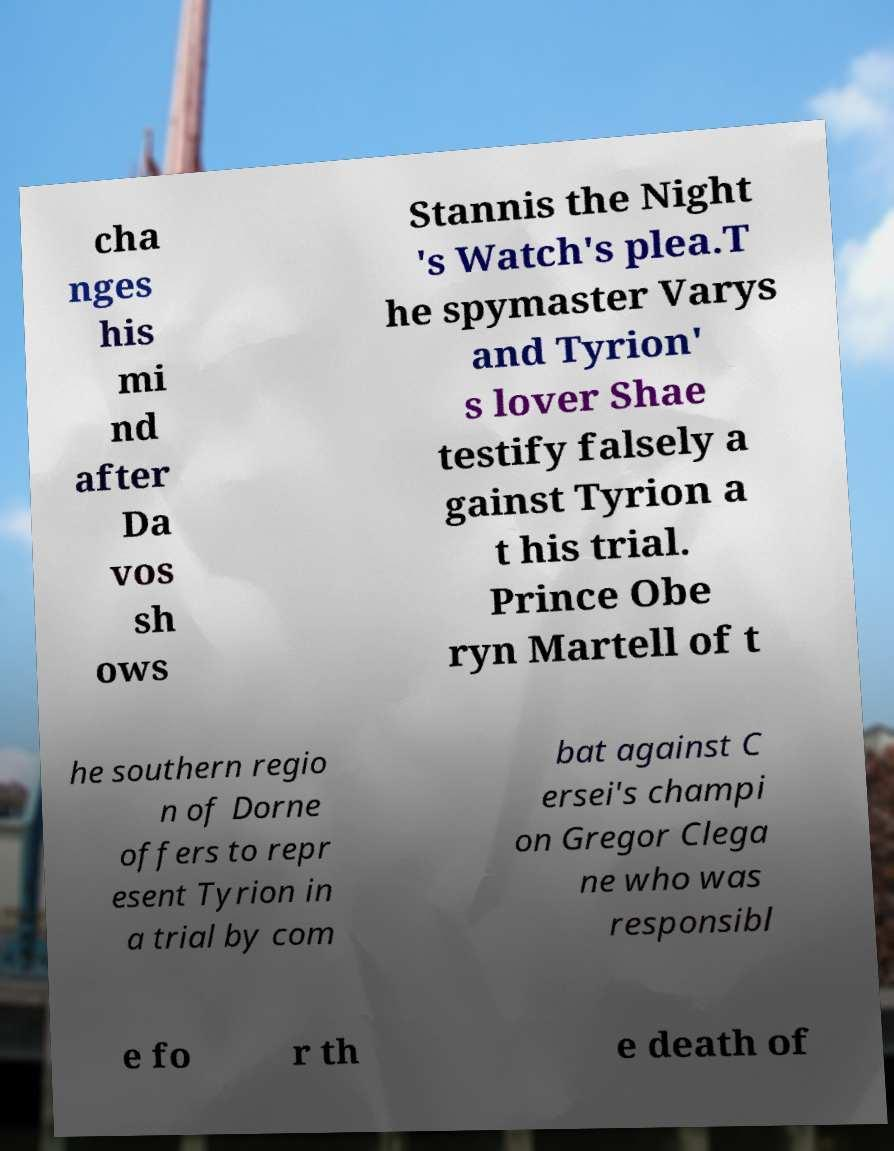Can you accurately transcribe the text from the provided image for me? cha nges his mi nd after Da vos sh ows Stannis the Night 's Watch's plea.T he spymaster Varys and Tyrion' s lover Shae testify falsely a gainst Tyrion a t his trial. Prince Obe ryn Martell of t he southern regio n of Dorne offers to repr esent Tyrion in a trial by com bat against C ersei's champi on Gregor Clega ne who was responsibl e fo r th e death of 